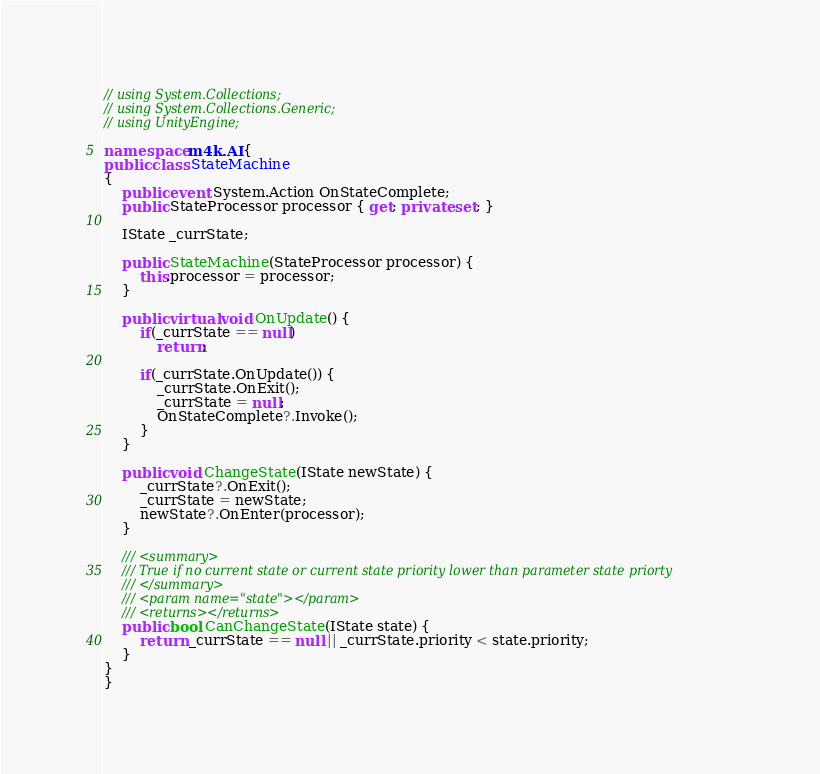Convert code to text. <code><loc_0><loc_0><loc_500><loc_500><_C#_>// using System.Collections;
// using System.Collections.Generic;
// using UnityEngine;

namespace m4k.AI {
public class StateMachine
{
    public event System.Action OnStateComplete;
    public StateProcessor processor { get; private set; }
    
    IState _currState;

    public StateMachine(StateProcessor processor) {
        this.processor = processor;
    }

    public virtual void OnUpdate() {
        if(_currState == null)
            return;

        if(_currState.OnUpdate()) {
            _currState.OnExit();
            _currState = null;
            OnStateComplete?.Invoke();
        }
    }

    public void ChangeState(IState newState) {
        _currState?.OnExit();
        _currState = newState;
        newState?.OnEnter(processor);
    }

    /// <summary>
    /// True if no current state or current state priority lower than parameter state priorty
    /// </summary>
    /// <param name="state"></param>
    /// <returns></returns>
    public bool CanChangeState(IState state) {
        return _currState == null || _currState.priority < state.priority;
    }
}
}</code> 